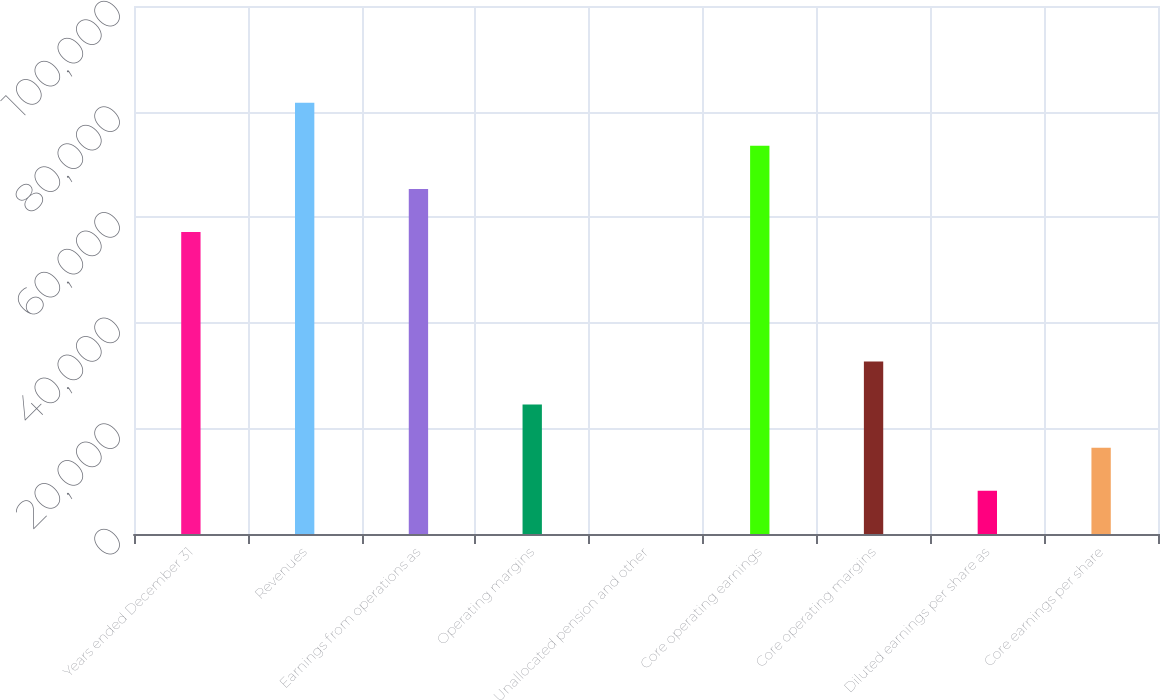Convert chart. <chart><loc_0><loc_0><loc_500><loc_500><bar_chart><fcel>Years ended December 31<fcel>Revenues<fcel>Earnings from operations as<fcel>Operating margins<fcel>Unallocated pension and other<fcel>Core operating earnings<fcel>Core operating margins<fcel>Diluted earnings per share as<fcel>Core earnings per share<nl><fcel>57188.8<fcel>81698<fcel>65358.5<fcel>24509.9<fcel>0.77<fcel>73528.2<fcel>32679.7<fcel>8170.49<fcel>16340.2<nl></chart> 